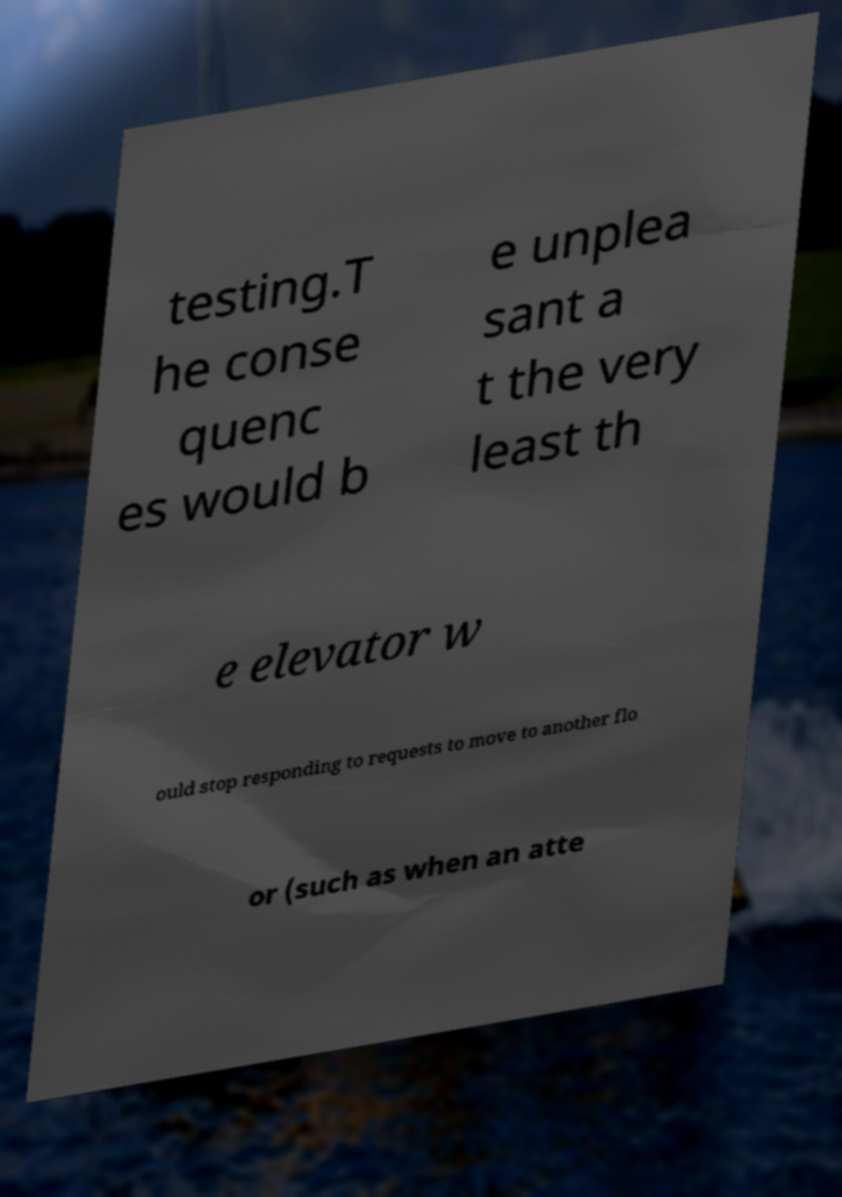Can you read and provide the text displayed in the image?This photo seems to have some interesting text. Can you extract and type it out for me? testing.T he conse quenc es would b e unplea sant a t the very least th e elevator w ould stop responding to requests to move to another flo or (such as when an atte 